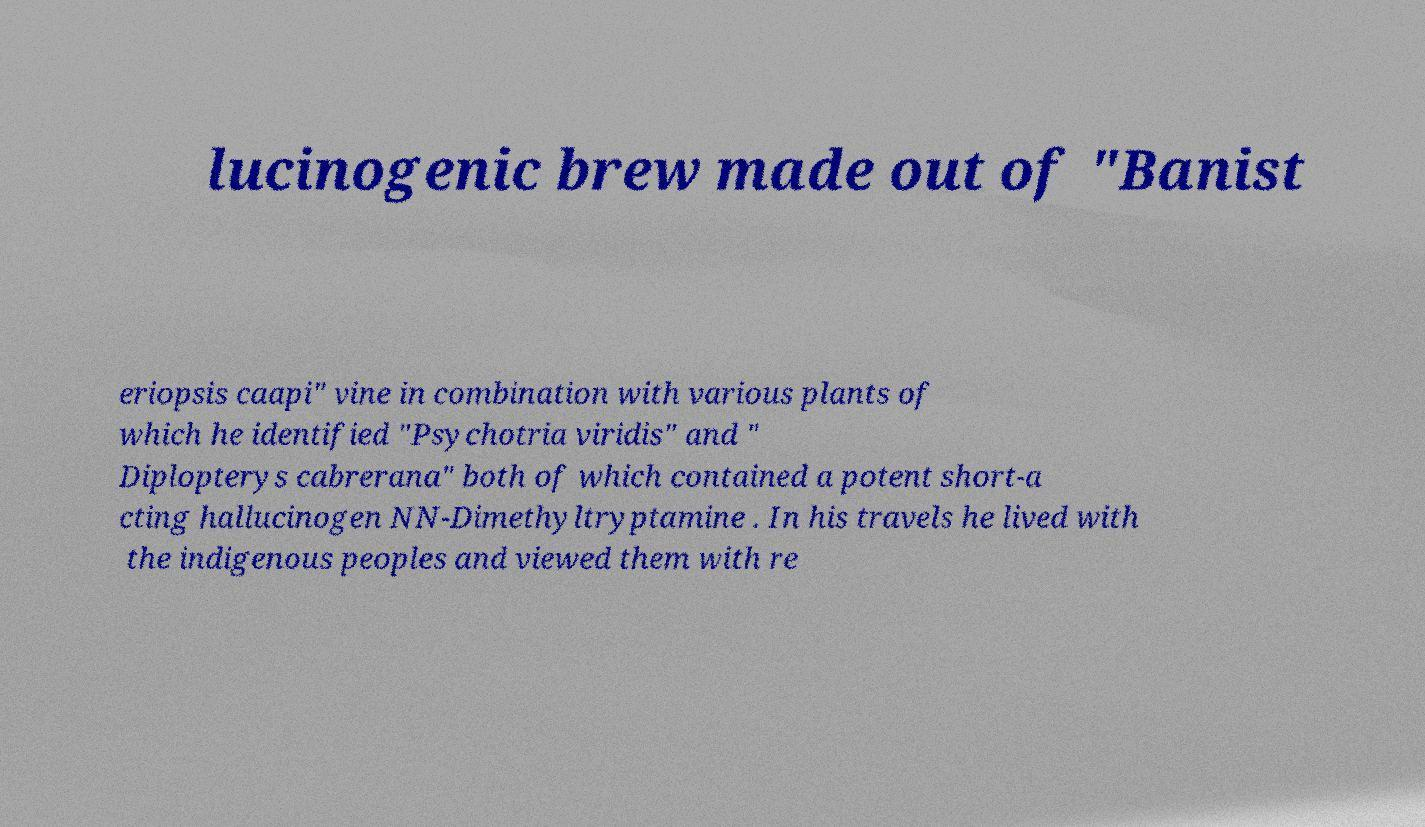Could you assist in decoding the text presented in this image and type it out clearly? lucinogenic brew made out of "Banist eriopsis caapi" vine in combination with various plants of which he identified "Psychotria viridis" and " Diplopterys cabrerana" both of which contained a potent short-a cting hallucinogen NN-Dimethyltryptamine . In his travels he lived with the indigenous peoples and viewed them with re 